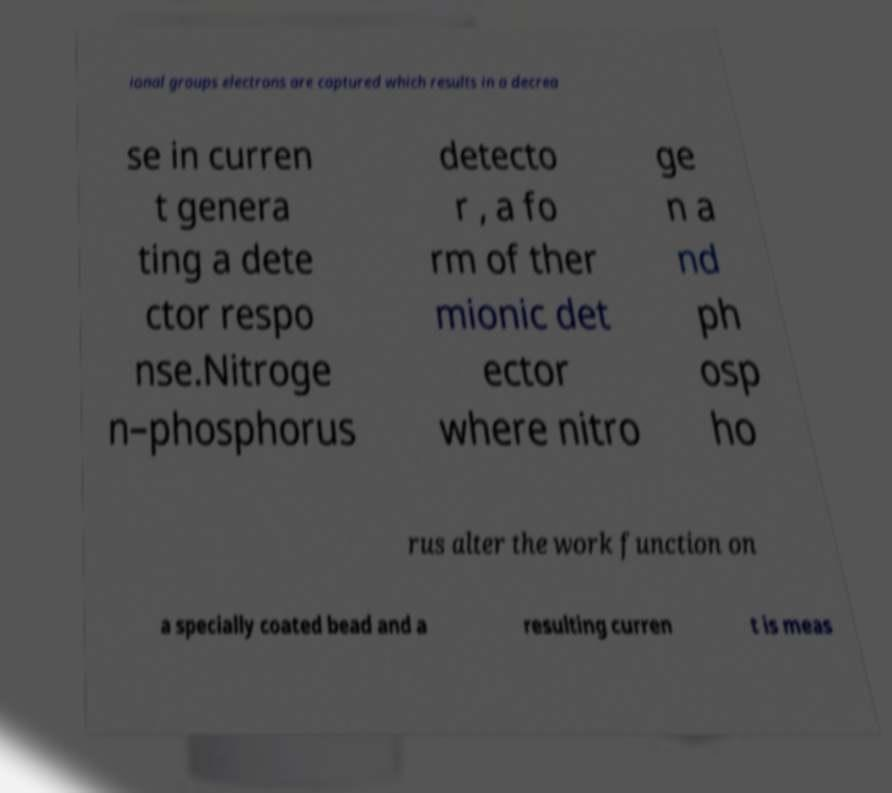There's text embedded in this image that I need extracted. Can you transcribe it verbatim? ional groups electrons are captured which results in a decrea se in curren t genera ting a dete ctor respo nse.Nitroge n–phosphorus detecto r , a fo rm of ther mionic det ector where nitro ge n a nd ph osp ho rus alter the work function on a specially coated bead and a resulting curren t is meas 